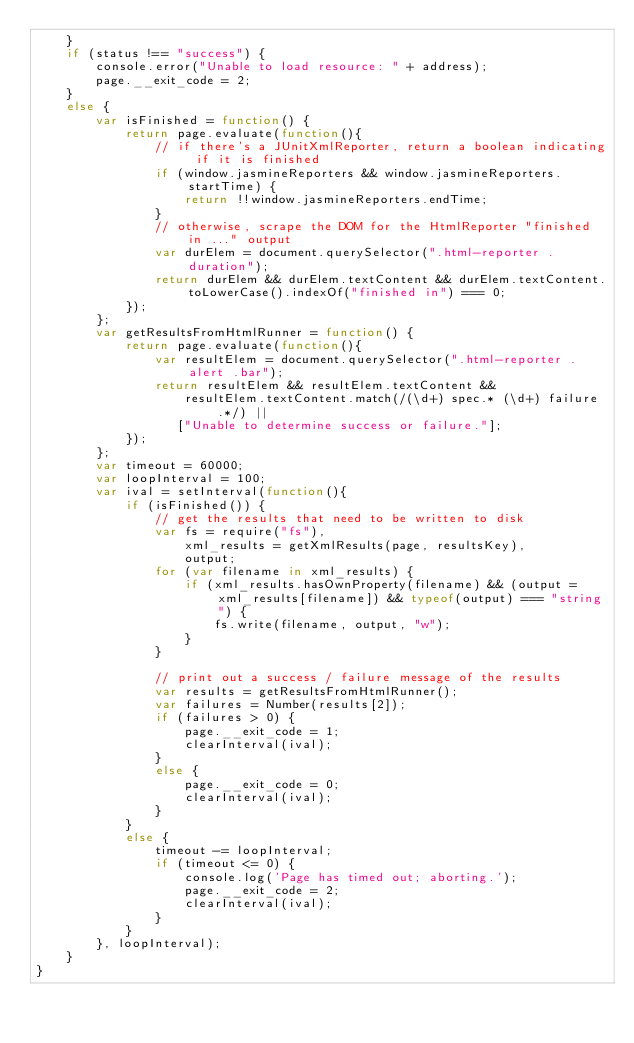Convert code to text. <code><loc_0><loc_0><loc_500><loc_500><_JavaScript_>    }
    if (status !== "success") {
        console.error("Unable to load resource: " + address);
        page.__exit_code = 2;
    }
    else {
        var isFinished = function() {
            return page.evaluate(function(){
                // if there's a JUnitXmlReporter, return a boolean indicating if it is finished
                if (window.jasmineReporters && window.jasmineReporters.startTime) {
                    return !!window.jasmineReporters.endTime;
                }
                // otherwise, scrape the DOM for the HtmlReporter "finished in ..." output
                var durElem = document.querySelector(".html-reporter .duration");
                return durElem && durElem.textContent && durElem.textContent.toLowerCase().indexOf("finished in") === 0;
            });
        };
        var getResultsFromHtmlRunner = function() {
            return page.evaluate(function(){
                var resultElem = document.querySelector(".html-reporter .alert .bar");
                return resultElem && resultElem.textContent &&
                    resultElem.textContent.match(/(\d+) spec.* (\d+) failure.*/) ||
                   ["Unable to determine success or failure."];
            });
        };
        var timeout = 60000;
        var loopInterval = 100;
        var ival = setInterval(function(){
            if (isFinished()) {
                // get the results that need to be written to disk
                var fs = require("fs"),
                    xml_results = getXmlResults(page, resultsKey),
                    output;
                for (var filename in xml_results) {
                    if (xml_results.hasOwnProperty(filename) && (output = xml_results[filename]) && typeof(output) === "string") {
                        fs.write(filename, output, "w");
                    }
                }

                // print out a success / failure message of the results
                var results = getResultsFromHtmlRunner();
                var failures = Number(results[2]);
                if (failures > 0) {
                    page.__exit_code = 1;
                    clearInterval(ival);
                }
                else {
                    page.__exit_code = 0;
                    clearInterval(ival);
                }
            }
            else {
                timeout -= loopInterval;
                if (timeout <= 0) {
                    console.log('Page has timed out; aborting.');
                    page.__exit_code = 2;
                    clearInterval(ival);
                }
            }
        }, loopInterval);
    }
}
</code> 